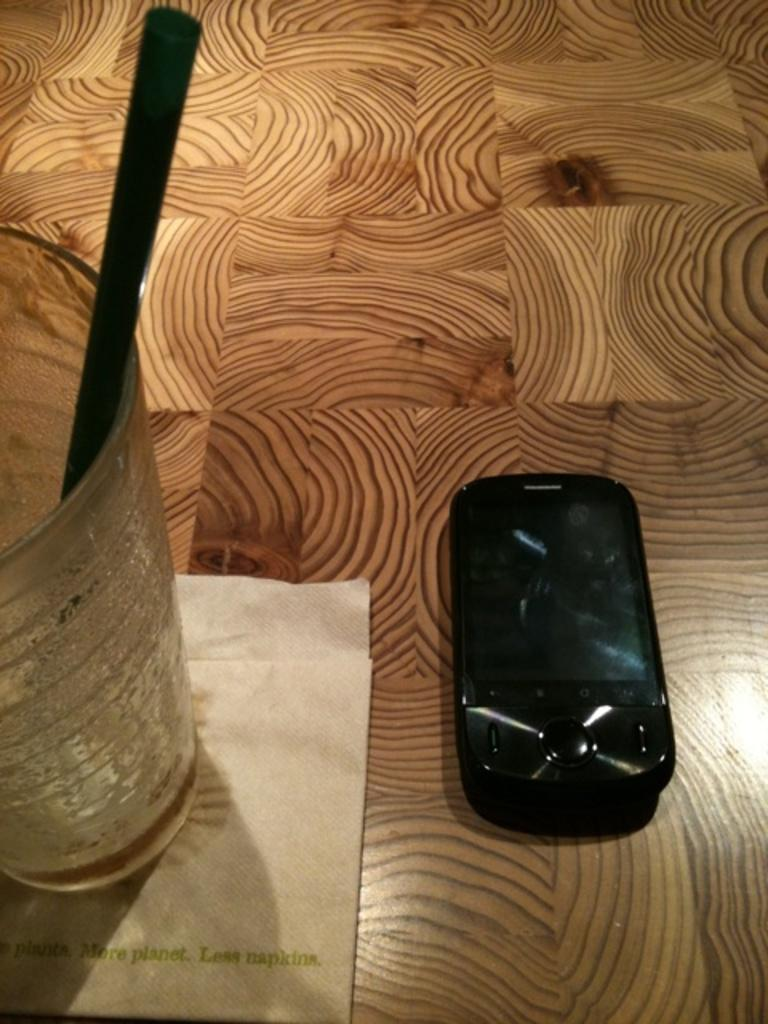<image>
Give a short and clear explanation of the subsequent image. an empty cup on a napkin reading More planet Less napkins and a black cell phone on a floor 